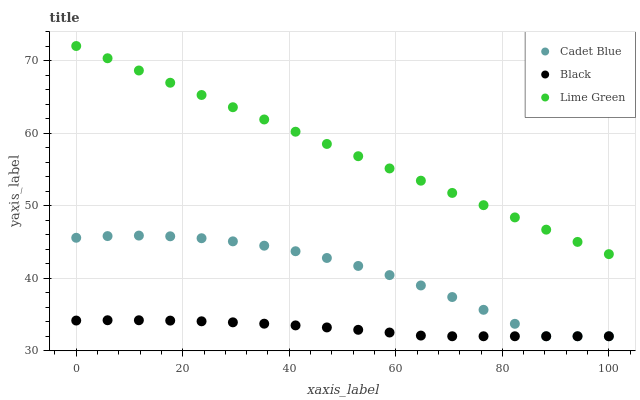Does Black have the minimum area under the curve?
Answer yes or no. Yes. Does Lime Green have the maximum area under the curve?
Answer yes or no. Yes. Does Cadet Blue have the minimum area under the curve?
Answer yes or no. No. Does Cadet Blue have the maximum area under the curve?
Answer yes or no. No. Is Lime Green the smoothest?
Answer yes or no. Yes. Is Cadet Blue the roughest?
Answer yes or no. Yes. Is Black the smoothest?
Answer yes or no. No. Is Black the roughest?
Answer yes or no. No. Does Cadet Blue have the lowest value?
Answer yes or no. Yes. Does Lime Green have the highest value?
Answer yes or no. Yes. Does Cadet Blue have the highest value?
Answer yes or no. No. Is Black less than Lime Green?
Answer yes or no. Yes. Is Lime Green greater than Cadet Blue?
Answer yes or no. Yes. Does Cadet Blue intersect Black?
Answer yes or no. Yes. Is Cadet Blue less than Black?
Answer yes or no. No. Is Cadet Blue greater than Black?
Answer yes or no. No. Does Black intersect Lime Green?
Answer yes or no. No. 